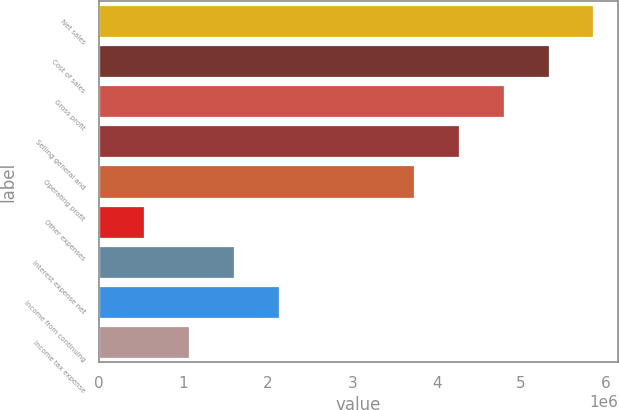Convert chart to OTSL. <chart><loc_0><loc_0><loc_500><loc_500><bar_chart><fcel>Net sales<fcel>Cost of sales<fcel>Gross profit<fcel>Selling general and<fcel>Operating profit<fcel>Other expenses<fcel>Interest expense net<fcel>Income from continuing<fcel>Income tax expense<nl><fcel>5.85722e+06<fcel>5.32475e+06<fcel>4.79227e+06<fcel>4.2598e+06<fcel>3.72732e+06<fcel>532476<fcel>1.59742e+06<fcel>2.1299e+06<fcel>1.06495e+06<nl></chart> 